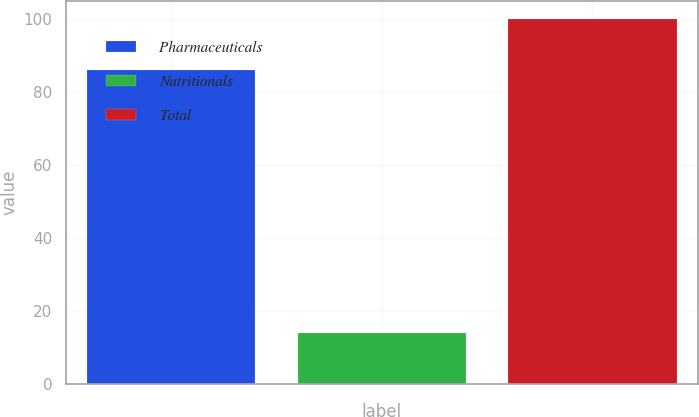Convert chart to OTSL. <chart><loc_0><loc_0><loc_500><loc_500><bar_chart><fcel>Pharmaceuticals<fcel>Nutritionals<fcel>Total<nl><fcel>86<fcel>14<fcel>100<nl></chart> 